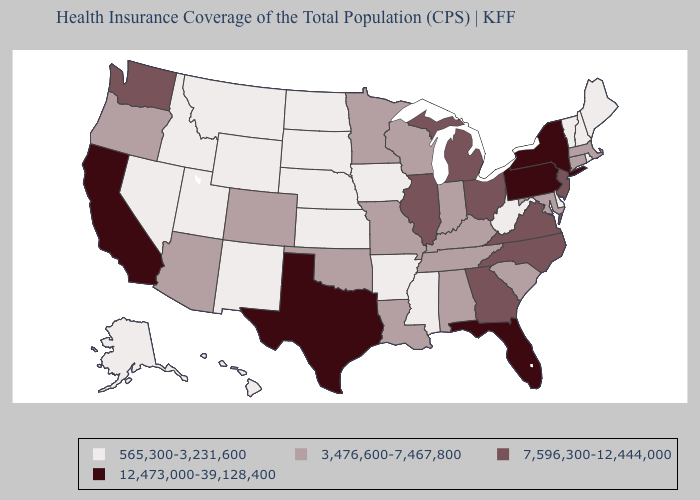What is the value of Kansas?
Be succinct. 565,300-3,231,600. Which states hav the highest value in the MidWest?
Be succinct. Illinois, Michigan, Ohio. Among the states that border Maryland , which have the lowest value?
Answer briefly. Delaware, West Virginia. Name the states that have a value in the range 7,596,300-12,444,000?
Short answer required. Georgia, Illinois, Michigan, New Jersey, North Carolina, Ohio, Virginia, Washington. Which states have the lowest value in the West?
Answer briefly. Alaska, Hawaii, Idaho, Montana, Nevada, New Mexico, Utah, Wyoming. What is the value of South Carolina?
Be succinct. 3,476,600-7,467,800. Among the states that border New Hampshire , does Massachusetts have the lowest value?
Answer briefly. No. What is the highest value in the USA?
Be succinct. 12,473,000-39,128,400. Does Maine have the same value as New Hampshire?
Be succinct. Yes. Does Wyoming have the highest value in the West?
Write a very short answer. No. Does the first symbol in the legend represent the smallest category?
Give a very brief answer. Yes. What is the value of New Jersey?
Be succinct. 7,596,300-12,444,000. What is the value of Indiana?
Short answer required. 3,476,600-7,467,800. Among the states that border Florida , does Alabama have the lowest value?
Be succinct. Yes. What is the lowest value in the South?
Give a very brief answer. 565,300-3,231,600. 